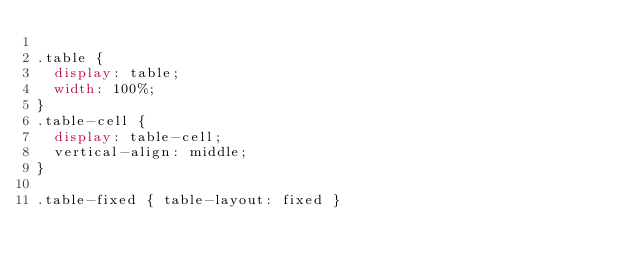Convert code to text. <code><loc_0><loc_0><loc_500><loc_500><_CSS_>
.table {
  display: table;
  width: 100%;
}
.table-cell {
  display: table-cell;
  vertical-align: middle;
}

.table-fixed { table-layout: fixed }

</code> 